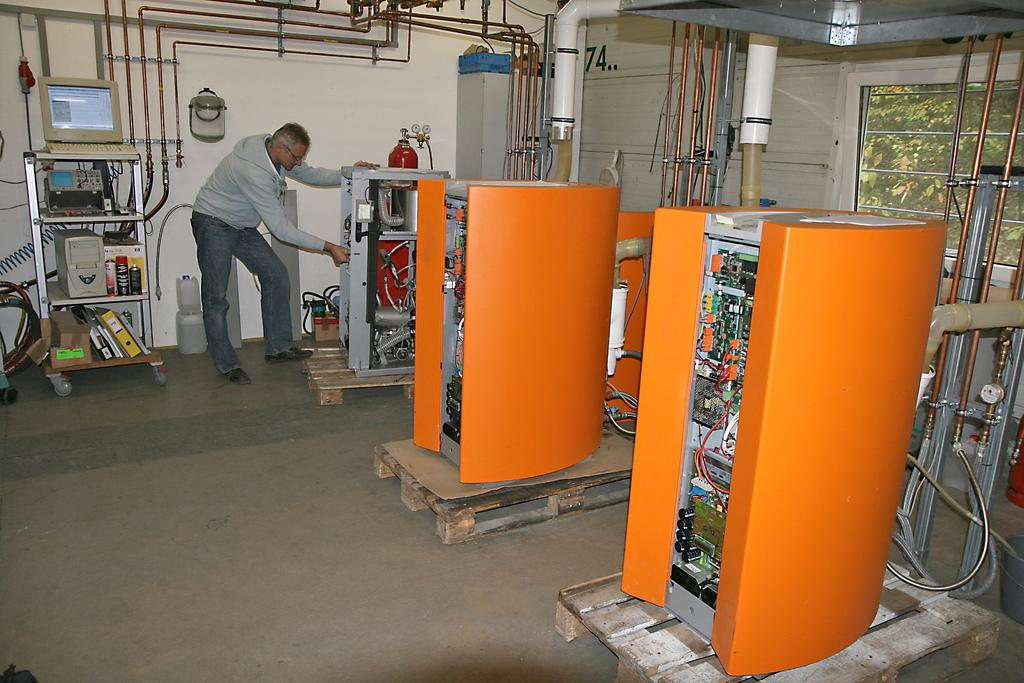<image>
Give a short and clear explanation of the subsequent image. Electronics wrapped in an orange barrier protection and 74 written on the back wall. 